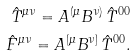Convert formula to latex. <formula><loc_0><loc_0><loc_500><loc_500>\hat { T } ^ { \mu \nu } = A ^ { ( \mu } B ^ { \nu ) } \, \hat { T } ^ { 0 0 } \\ \hat { F } ^ { \mu \nu } = A ^ { [ \mu } B ^ { \nu ] } \, \hat { T } ^ { 0 0 } .</formula> 